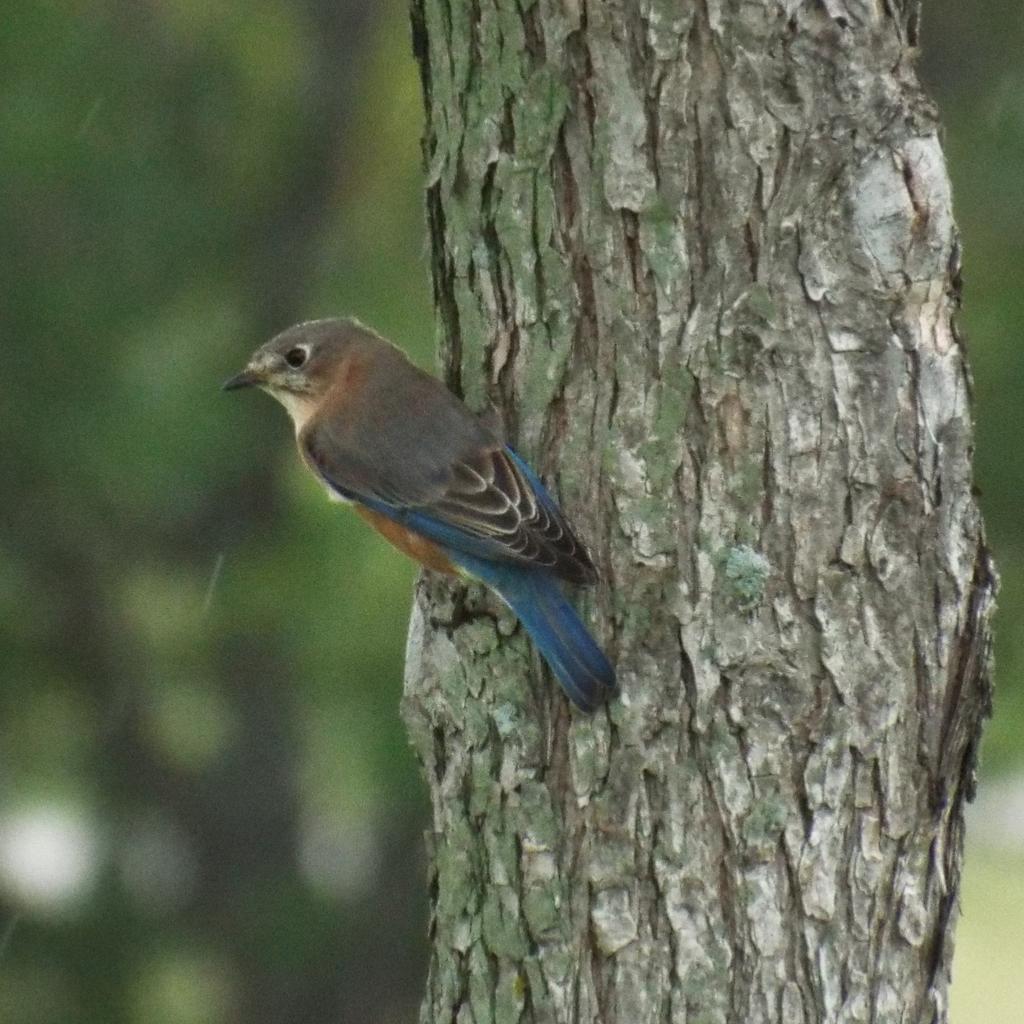Describe this image in one or two sentences. In this picture we can see a bird on a tree trunk and in the background it is blurry. 